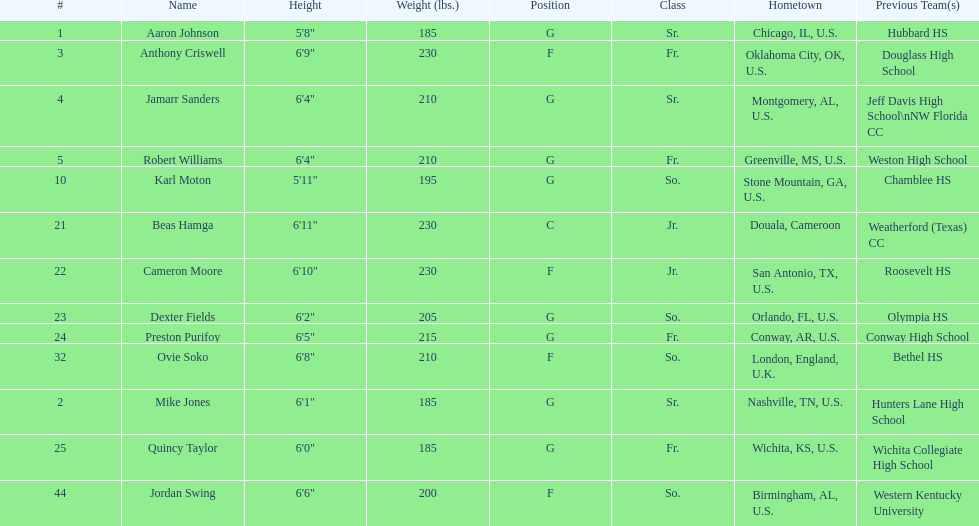Who is first on the roster? Aaron Johnson. 